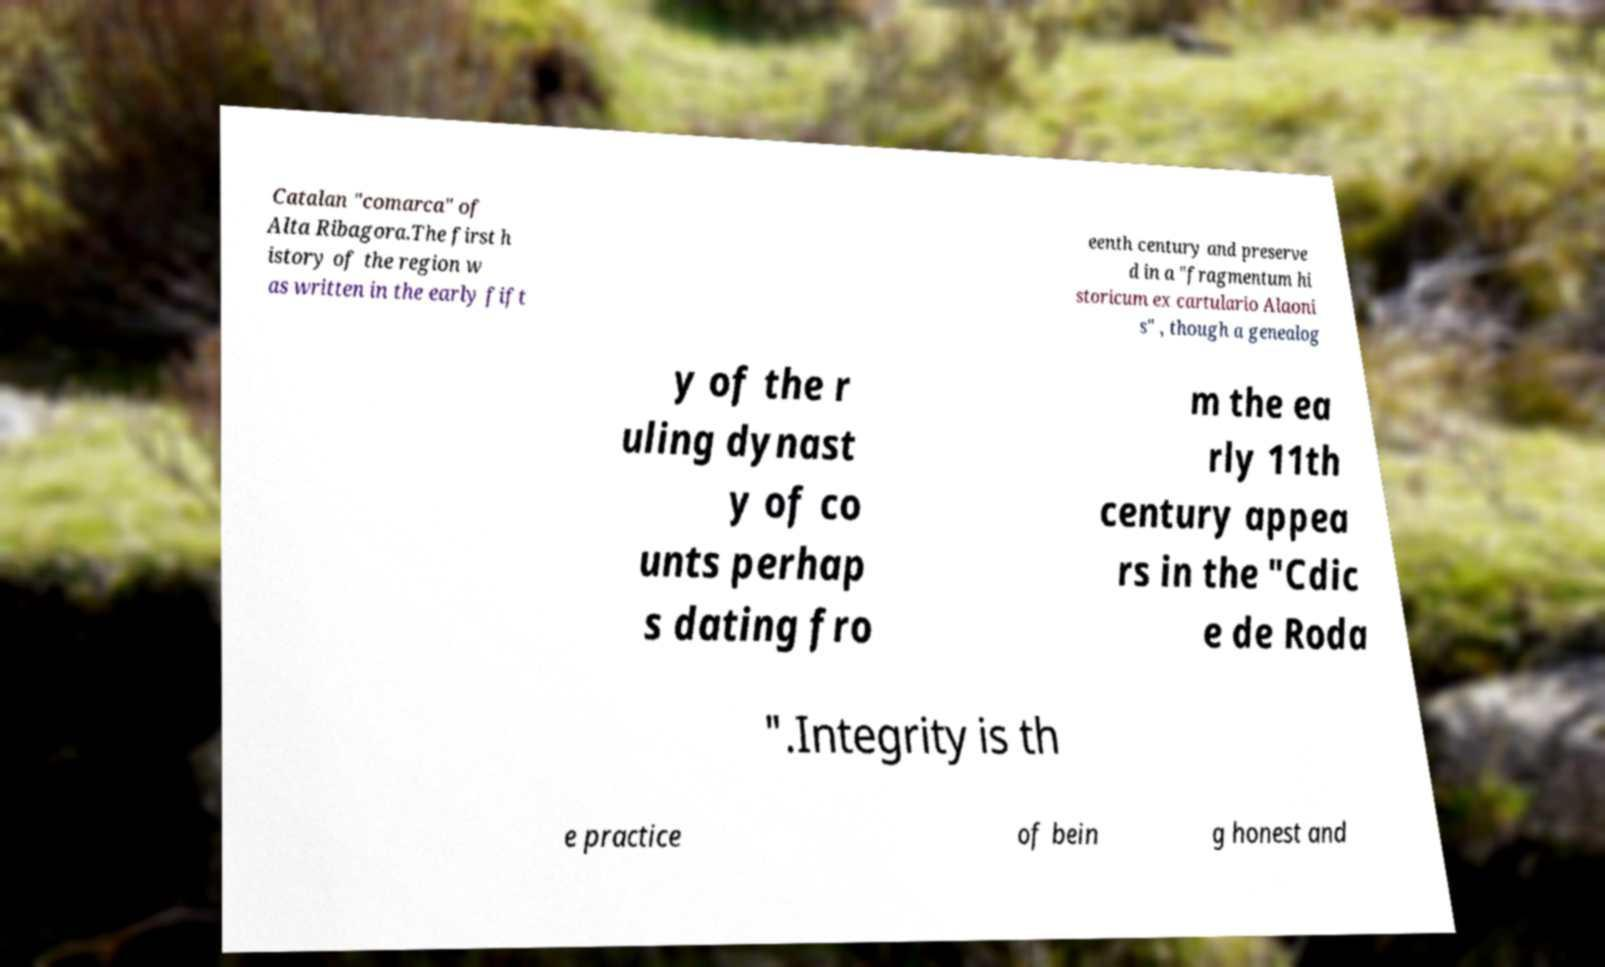I need the written content from this picture converted into text. Can you do that? Catalan "comarca" of Alta Ribagora.The first h istory of the region w as written in the early fift eenth century and preserve d in a "fragmentum hi storicum ex cartulario Alaoni s" , though a genealog y of the r uling dynast y of co unts perhap s dating fro m the ea rly 11th century appea rs in the "Cdic e de Roda ".Integrity is th e practice of bein g honest and 